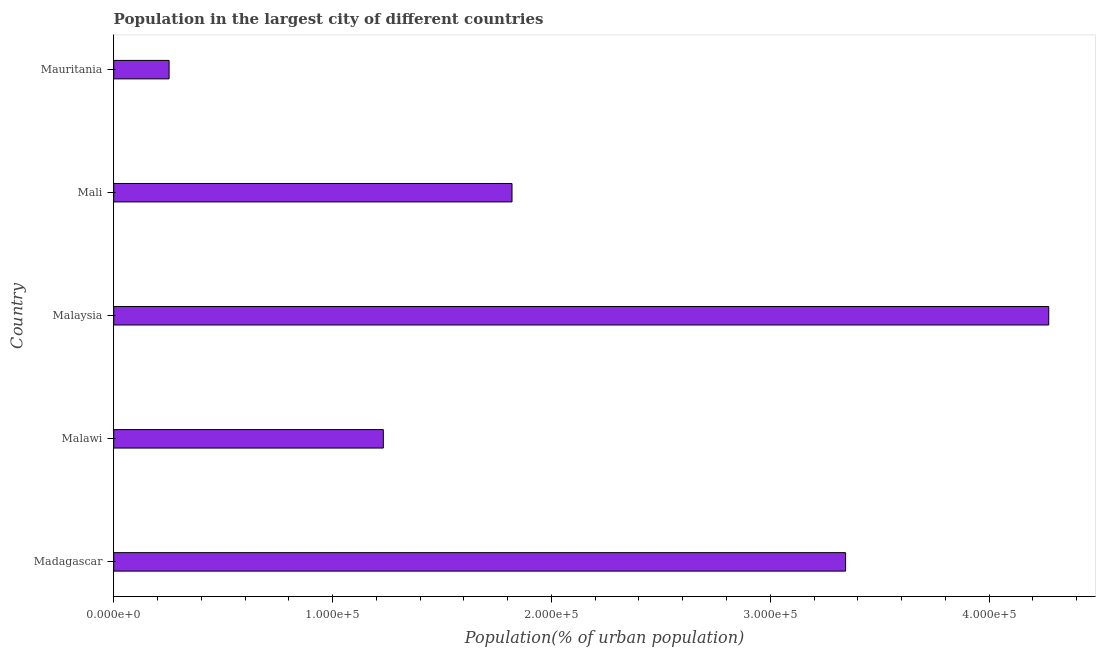Does the graph contain any zero values?
Give a very brief answer. No. Does the graph contain grids?
Ensure brevity in your answer.  No. What is the title of the graph?
Your response must be concise. Population in the largest city of different countries. What is the label or title of the X-axis?
Provide a succinct answer. Population(% of urban population). What is the population in largest city in Malaysia?
Make the answer very short. 4.27e+05. Across all countries, what is the maximum population in largest city?
Provide a short and direct response. 4.27e+05. Across all countries, what is the minimum population in largest city?
Keep it short and to the point. 2.53e+04. In which country was the population in largest city maximum?
Offer a very short reply. Malaysia. In which country was the population in largest city minimum?
Ensure brevity in your answer.  Mauritania. What is the sum of the population in largest city?
Give a very brief answer. 1.09e+06. What is the difference between the population in largest city in Mali and Mauritania?
Offer a terse response. 1.57e+05. What is the average population in largest city per country?
Offer a terse response. 2.18e+05. What is the median population in largest city?
Ensure brevity in your answer.  1.82e+05. What is the ratio of the population in largest city in Madagascar to that in Malawi?
Keep it short and to the point. 2.71. Is the population in largest city in Malawi less than that in Mauritania?
Give a very brief answer. No. What is the difference between the highest and the second highest population in largest city?
Keep it short and to the point. 9.28e+04. Is the sum of the population in largest city in Malawi and Mali greater than the maximum population in largest city across all countries?
Your response must be concise. No. What is the difference between the highest and the lowest population in largest city?
Offer a very short reply. 4.02e+05. In how many countries, is the population in largest city greater than the average population in largest city taken over all countries?
Provide a short and direct response. 2. How many countries are there in the graph?
Give a very brief answer. 5. What is the difference between two consecutive major ticks on the X-axis?
Provide a succinct answer. 1.00e+05. Are the values on the major ticks of X-axis written in scientific E-notation?
Keep it short and to the point. Yes. What is the Population(% of urban population) of Madagascar?
Offer a terse response. 3.34e+05. What is the Population(% of urban population) of Malawi?
Your answer should be very brief. 1.23e+05. What is the Population(% of urban population) of Malaysia?
Ensure brevity in your answer.  4.27e+05. What is the Population(% of urban population) in Mali?
Provide a short and direct response. 1.82e+05. What is the Population(% of urban population) of Mauritania?
Your answer should be compact. 2.53e+04. What is the difference between the Population(% of urban population) in Madagascar and Malawi?
Your answer should be compact. 2.11e+05. What is the difference between the Population(% of urban population) in Madagascar and Malaysia?
Ensure brevity in your answer.  -9.28e+04. What is the difference between the Population(% of urban population) in Madagascar and Mali?
Your response must be concise. 1.52e+05. What is the difference between the Population(% of urban population) in Madagascar and Mauritania?
Your response must be concise. 3.09e+05. What is the difference between the Population(% of urban population) in Malawi and Malaysia?
Ensure brevity in your answer.  -3.04e+05. What is the difference between the Population(% of urban population) in Malawi and Mali?
Provide a short and direct response. -5.88e+04. What is the difference between the Population(% of urban population) in Malawi and Mauritania?
Your answer should be compact. 9.79e+04. What is the difference between the Population(% of urban population) in Malaysia and Mali?
Your answer should be very brief. 2.45e+05. What is the difference between the Population(% of urban population) in Malaysia and Mauritania?
Your response must be concise. 4.02e+05. What is the difference between the Population(% of urban population) in Mali and Mauritania?
Your answer should be compact. 1.57e+05. What is the ratio of the Population(% of urban population) in Madagascar to that in Malawi?
Offer a very short reply. 2.71. What is the ratio of the Population(% of urban population) in Madagascar to that in Malaysia?
Your answer should be compact. 0.78. What is the ratio of the Population(% of urban population) in Madagascar to that in Mali?
Your response must be concise. 1.84. What is the ratio of the Population(% of urban population) in Madagascar to that in Mauritania?
Your response must be concise. 13.22. What is the ratio of the Population(% of urban population) in Malawi to that in Malaysia?
Give a very brief answer. 0.29. What is the ratio of the Population(% of urban population) in Malawi to that in Mali?
Offer a terse response. 0.68. What is the ratio of the Population(% of urban population) in Malawi to that in Mauritania?
Offer a terse response. 4.87. What is the ratio of the Population(% of urban population) in Malaysia to that in Mali?
Provide a short and direct response. 2.35. What is the ratio of the Population(% of urban population) in Malaysia to that in Mauritania?
Make the answer very short. 16.89. What is the ratio of the Population(% of urban population) in Mali to that in Mauritania?
Offer a very short reply. 7.2. 